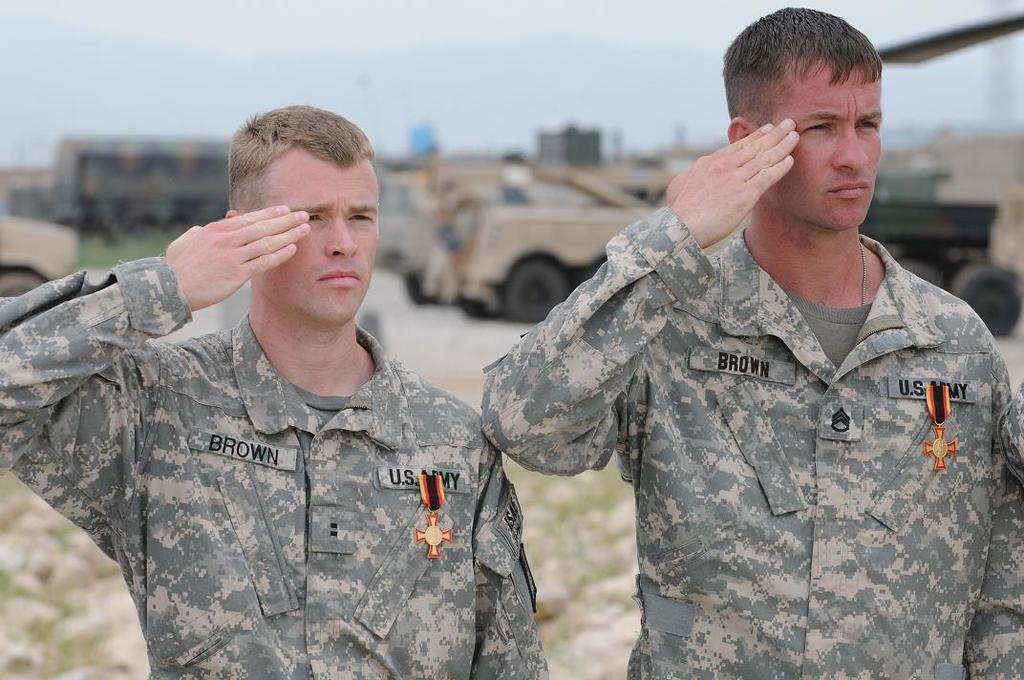How would you summarize this image in a sentence or two? In this picture there are two persons standing. They are soldiers. In the background there are some vehicles. We can observe sky here. 